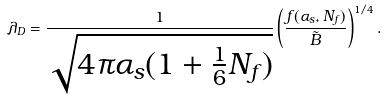Convert formula to latex. <formula><loc_0><loc_0><loc_500><loc_500>\lambda _ { D } = { \frac { 1 } { \sqrt { 4 \pi \alpha _ { s } ( 1 + { \frac { 1 } { 6 } } N _ { f } ) } } } \left ( { \frac { f ( \alpha _ { s } , N _ { f } ) } { \tilde { B } } } \right ) ^ { 1 / 4 } .</formula> 